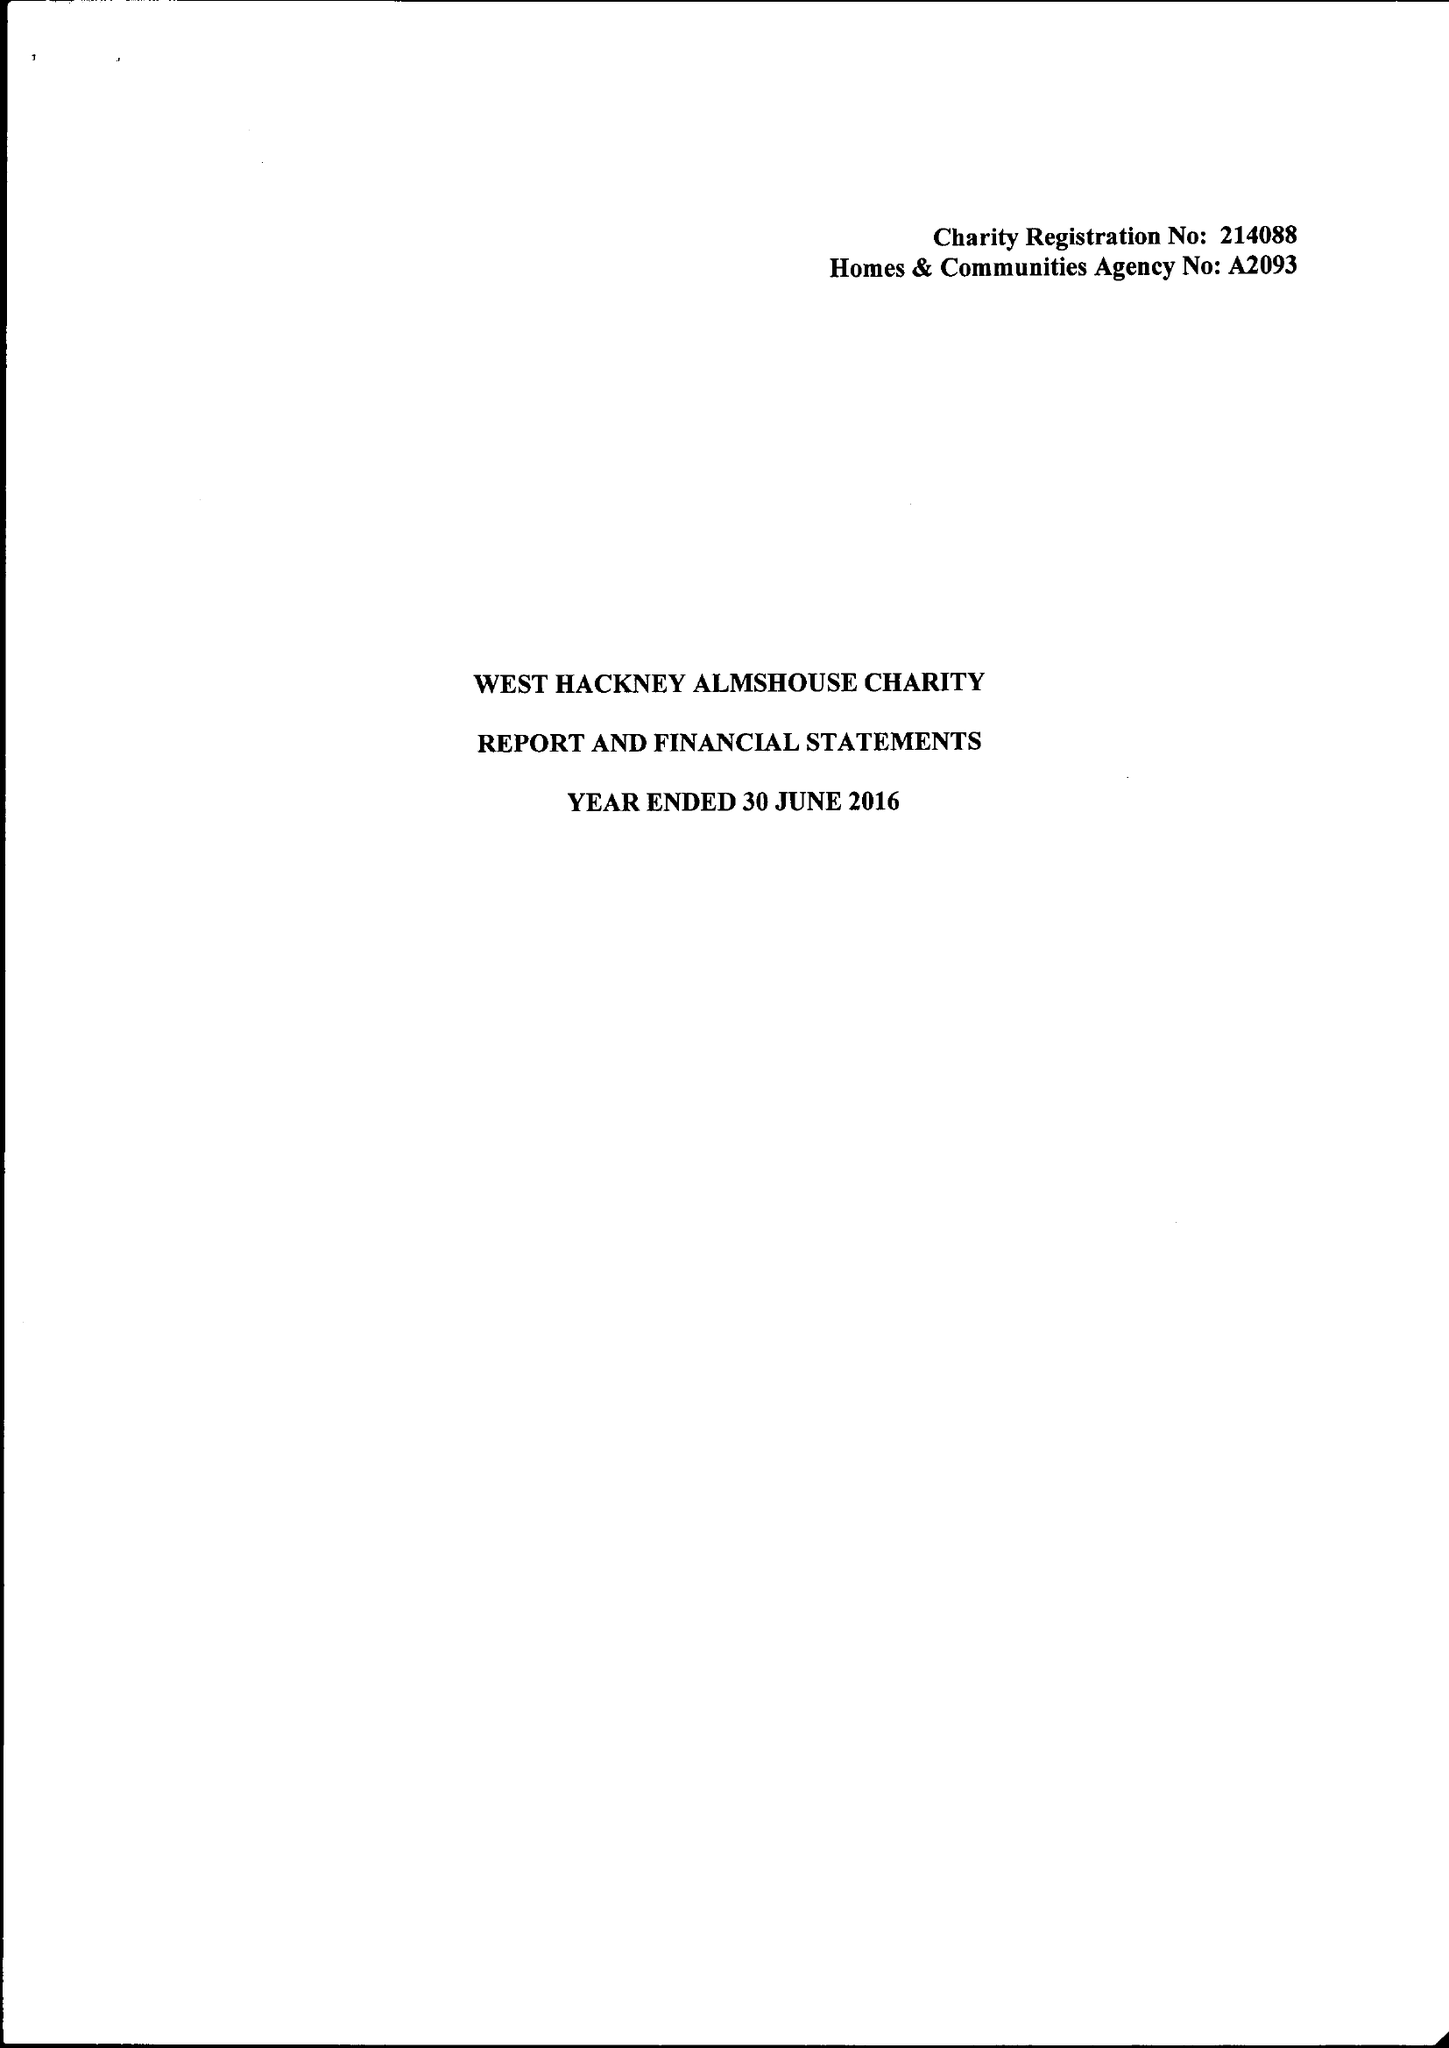What is the value for the report_date?
Answer the question using a single word or phrase. 2016-06-30 